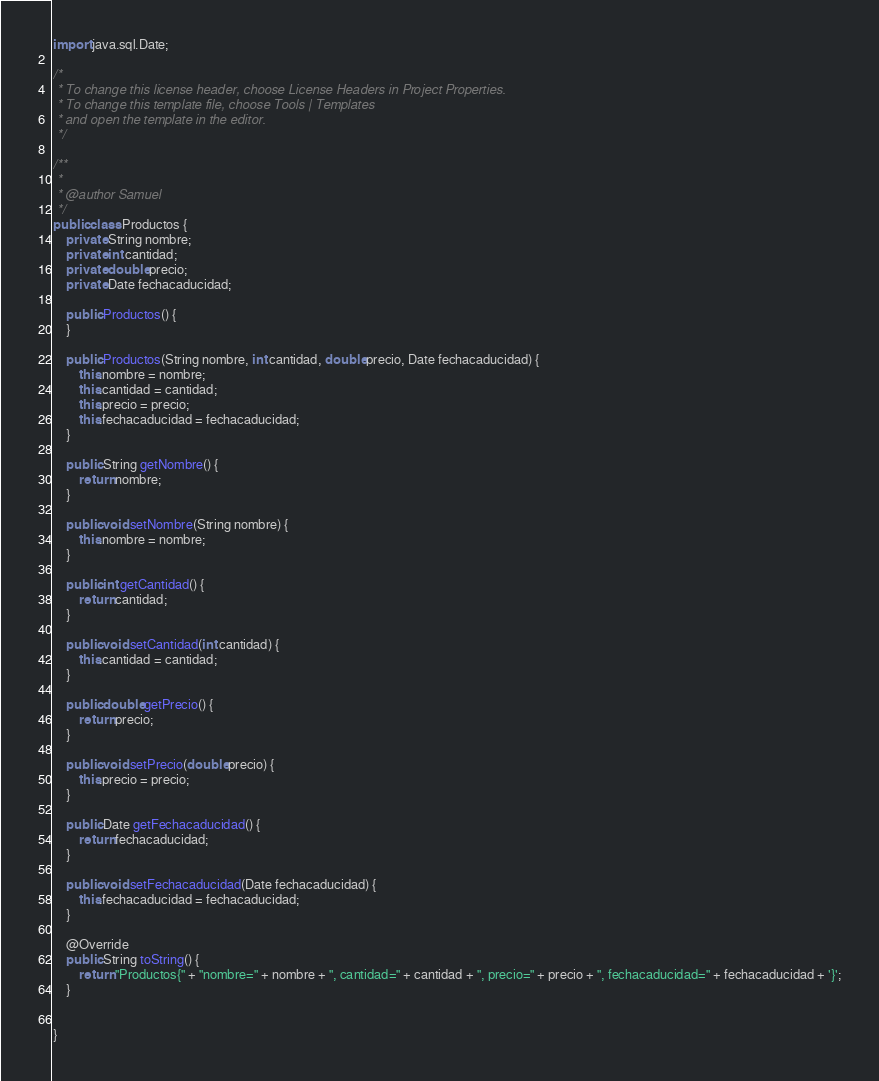<code> <loc_0><loc_0><loc_500><loc_500><_Java_>import java.sql.Date;

/*
 * To change this license header, choose License Headers in Project Properties.
 * To change this template file, choose Tools | Templates
 * and open the template in the editor.
 */

/**
 *
 * @author Samuel
 */
public class Productos {
    private String nombre;
    private int cantidad;
    private double precio;
    private Date fechacaducidad;

    public Productos() {
    }

    public Productos(String nombre, int cantidad, double precio, Date fechacaducidad) {
        this.nombre = nombre;
        this.cantidad = cantidad;
        this.precio = precio;
        this.fechacaducidad = fechacaducidad;
    }

    public String getNombre() {
        return nombre;
    }

    public void setNombre(String nombre) {
        this.nombre = nombre;
    }

    public int getCantidad() {
        return cantidad;
    }

    public void setCantidad(int cantidad) {
        this.cantidad = cantidad;
    }

    public double getPrecio() {
        return precio;
    }

    public void setPrecio(double precio) {
        this.precio = precio;
    }

    public Date getFechacaducidad() {
        return fechacaducidad;
    }

    public void setFechacaducidad(Date fechacaducidad) {
        this.fechacaducidad = fechacaducidad;
    }

    @Override
    public String toString() {
        return "Productos{" + "nombre=" + nombre + ", cantidad=" + cantidad + ", precio=" + precio + ", fechacaducidad=" + fechacaducidad + '}';
    }
    
    
}
</code> 